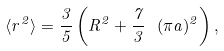Convert formula to latex. <formula><loc_0><loc_0><loc_500><loc_500>\langle r ^ { 2 } \rangle = \frac { 3 } { 5 } \left ( R ^ { 2 } + \frac { 7 } { 3 } \ ( \pi a ) ^ { 2 } \right ) ,</formula> 